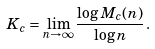<formula> <loc_0><loc_0><loc_500><loc_500>K _ { c } = \lim _ { n \to \infty } \frac { \log { M } _ { c } ( n ) } { \log n } \, .</formula> 